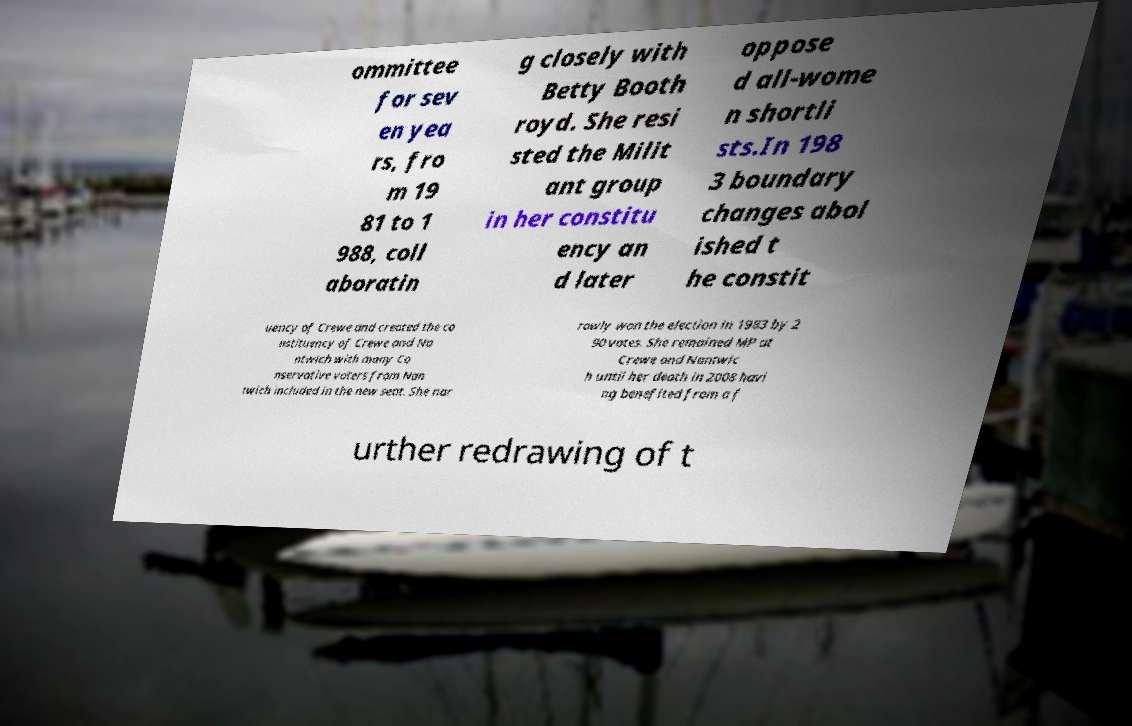Can you accurately transcribe the text from the provided image for me? ommittee for sev en yea rs, fro m 19 81 to 1 988, coll aboratin g closely with Betty Booth royd. She resi sted the Milit ant group in her constitu ency an d later oppose d all-wome n shortli sts.In 198 3 boundary changes abol ished t he constit uency of Crewe and created the co nstituency of Crewe and Na ntwich with many Co nservative voters from Nan twich included in the new seat. She nar rowly won the election in 1983 by 2 90 votes. She remained MP at Crewe and Nantwic h until her death in 2008 havi ng benefited from a f urther redrawing of t 